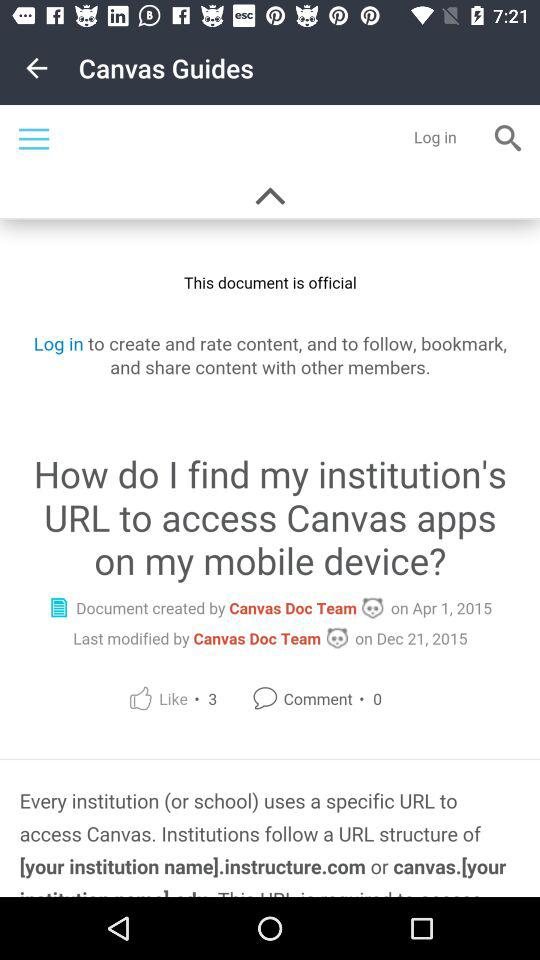How many thumbs up does the document have?
Answer the question using a single word or phrase. 3 